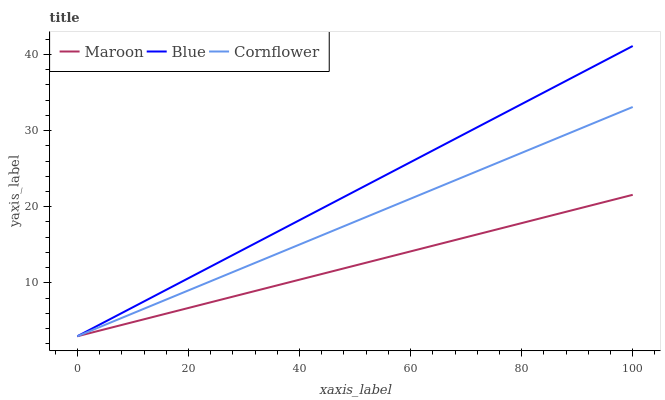Does Maroon have the minimum area under the curve?
Answer yes or no. Yes. Does Blue have the maximum area under the curve?
Answer yes or no. Yes. Does Cornflower have the minimum area under the curve?
Answer yes or no. No. Does Cornflower have the maximum area under the curve?
Answer yes or no. No. Is Maroon the smoothest?
Answer yes or no. Yes. Is Blue the roughest?
Answer yes or no. Yes. Is Cornflower the smoothest?
Answer yes or no. No. Is Cornflower the roughest?
Answer yes or no. No. Does Blue have the lowest value?
Answer yes or no. Yes. Does Blue have the highest value?
Answer yes or no. Yes. Does Cornflower have the highest value?
Answer yes or no. No. Does Maroon intersect Blue?
Answer yes or no. Yes. Is Maroon less than Blue?
Answer yes or no. No. Is Maroon greater than Blue?
Answer yes or no. No. 